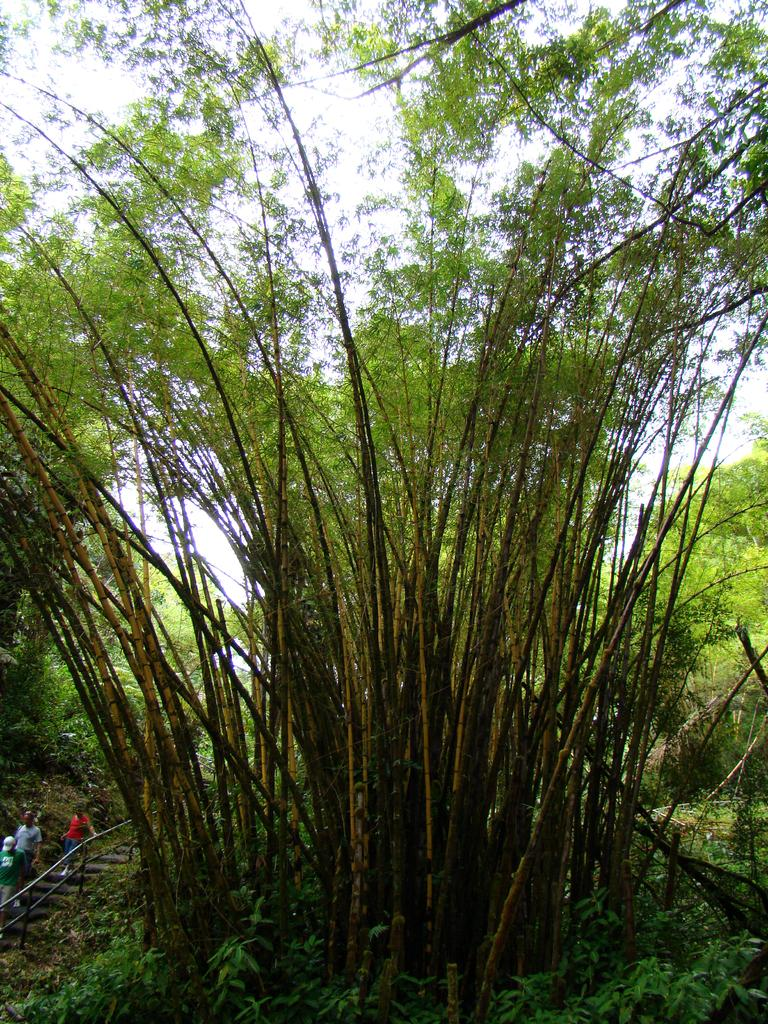What type of vegetation can be seen in the image? There are trees in the image. What is the color of the trees? The trees are green. What can be seen in the background of the image? There are people walking and steps in the background. What is the color of the sky in the image? The sky is white in color. How many babies are crawling on the trees in the image? There are no babies present in the image, and they are not crawling on the trees. 